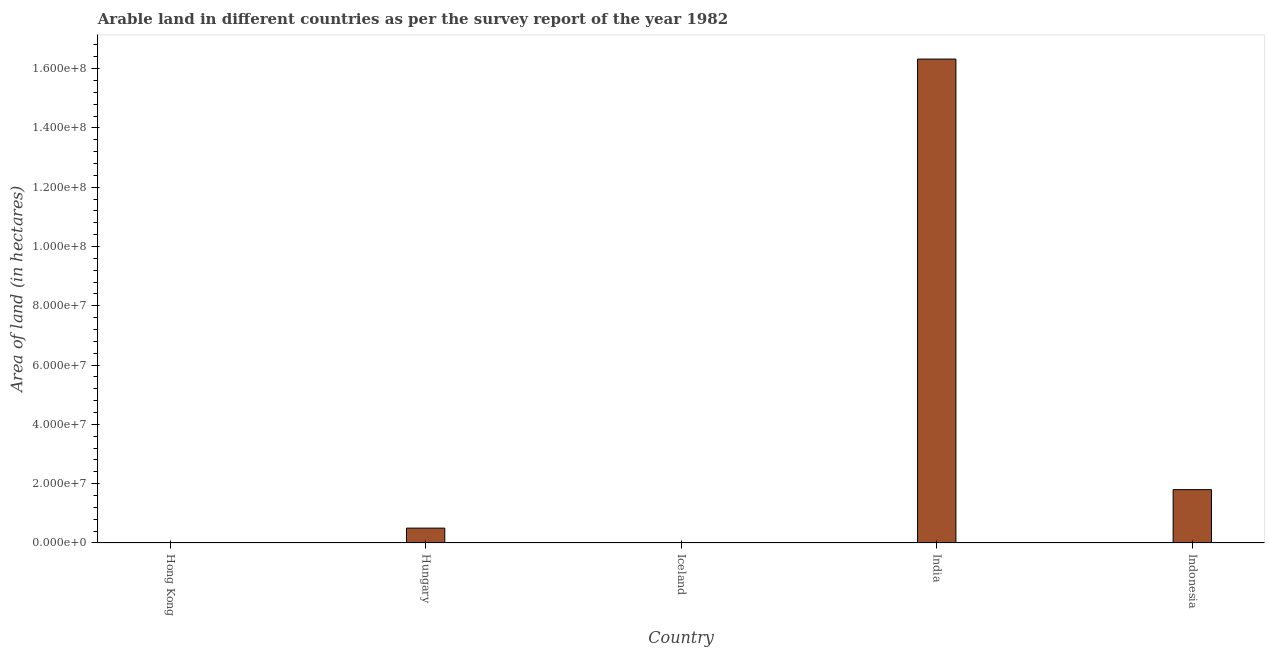Does the graph contain any zero values?
Your answer should be very brief. No. What is the title of the graph?
Your answer should be compact. Arable land in different countries as per the survey report of the year 1982. What is the label or title of the Y-axis?
Offer a terse response. Area of land (in hectares). What is the area of land in Iceland?
Provide a short and direct response. 1.34e+05. Across all countries, what is the maximum area of land?
Provide a short and direct response. 1.63e+08. Across all countries, what is the minimum area of land?
Offer a terse response. 7000. In which country was the area of land minimum?
Offer a very short reply. Hong Kong. What is the sum of the area of land?
Ensure brevity in your answer.  1.86e+08. What is the difference between the area of land in Hungary and India?
Provide a short and direct response. -1.58e+08. What is the average area of land per country?
Your answer should be very brief. 3.73e+07. What is the median area of land?
Give a very brief answer. 5.02e+06. In how many countries, is the area of land greater than 76000000 hectares?
Offer a very short reply. 1. What is the ratio of the area of land in Iceland to that in India?
Your response must be concise. 0. Is the area of land in Hungary less than that in Iceland?
Make the answer very short. No. What is the difference between the highest and the second highest area of land?
Your answer should be very brief. 1.45e+08. Is the sum of the area of land in Hungary and Iceland greater than the maximum area of land across all countries?
Offer a terse response. No. What is the difference between the highest and the lowest area of land?
Make the answer very short. 1.63e+08. In how many countries, is the area of land greater than the average area of land taken over all countries?
Give a very brief answer. 1. Are all the bars in the graph horizontal?
Provide a succinct answer. No. What is the Area of land (in hectares) in Hong Kong?
Give a very brief answer. 7000. What is the Area of land (in hectares) of Hungary?
Give a very brief answer. 5.02e+06. What is the Area of land (in hectares) in Iceland?
Your answer should be compact. 1.34e+05. What is the Area of land (in hectares) in India?
Provide a succinct answer. 1.63e+08. What is the Area of land (in hectares) in Indonesia?
Ensure brevity in your answer.  1.80e+07. What is the difference between the Area of land (in hectares) in Hong Kong and Hungary?
Your answer should be compact. -5.01e+06. What is the difference between the Area of land (in hectares) in Hong Kong and Iceland?
Your response must be concise. -1.27e+05. What is the difference between the Area of land (in hectares) in Hong Kong and India?
Give a very brief answer. -1.63e+08. What is the difference between the Area of land (in hectares) in Hong Kong and Indonesia?
Provide a succinct answer. -1.80e+07. What is the difference between the Area of land (in hectares) in Hungary and Iceland?
Your answer should be very brief. 4.88e+06. What is the difference between the Area of land (in hectares) in Hungary and India?
Provide a short and direct response. -1.58e+08. What is the difference between the Area of land (in hectares) in Hungary and Indonesia?
Keep it short and to the point. -1.30e+07. What is the difference between the Area of land (in hectares) in Iceland and India?
Offer a very short reply. -1.63e+08. What is the difference between the Area of land (in hectares) in Iceland and Indonesia?
Provide a succinct answer. -1.79e+07. What is the difference between the Area of land (in hectares) in India and Indonesia?
Ensure brevity in your answer.  1.45e+08. What is the ratio of the Area of land (in hectares) in Hong Kong to that in Iceland?
Keep it short and to the point. 0.05. What is the ratio of the Area of land (in hectares) in Hong Kong to that in India?
Make the answer very short. 0. What is the ratio of the Area of land (in hectares) in Hungary to that in Iceland?
Make the answer very short. 37.45. What is the ratio of the Area of land (in hectares) in Hungary to that in India?
Offer a very short reply. 0.03. What is the ratio of the Area of land (in hectares) in Hungary to that in Indonesia?
Provide a succinct answer. 0.28. What is the ratio of the Area of land (in hectares) in Iceland to that in Indonesia?
Make the answer very short. 0.01. What is the ratio of the Area of land (in hectares) in India to that in Indonesia?
Offer a very short reply. 9.07. 